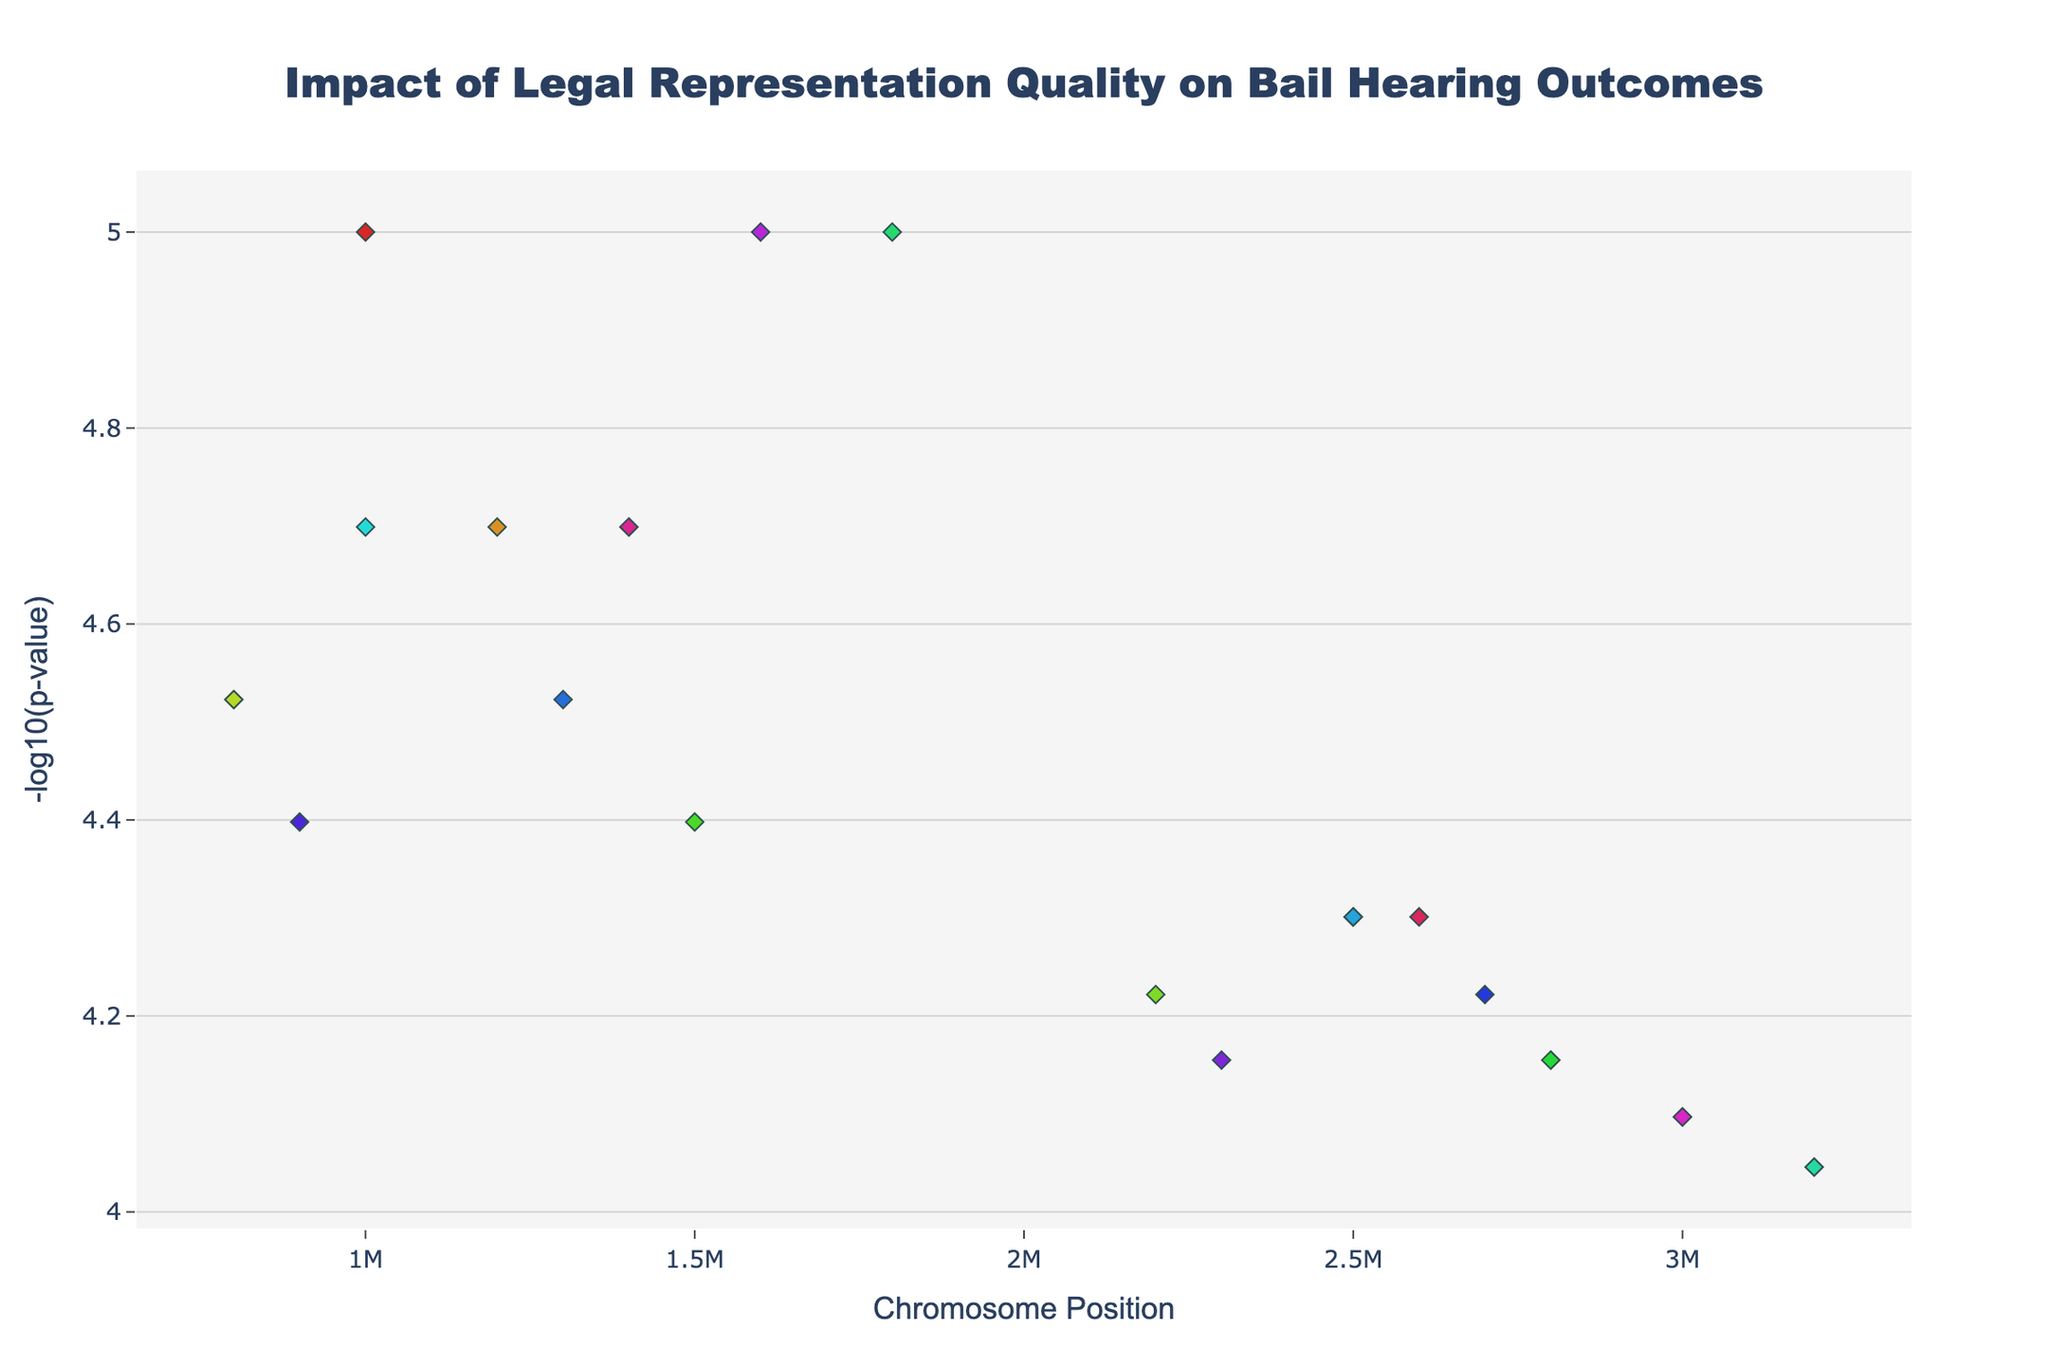What does the figure title say about the plot? The title of the plot is “Impact of Legal Representation Quality on Bail Hearing Outcomes.” It indicates that the plot is exploring how the quality of legal representation affects bail hearing outcomes.
Answer: Impact of Legal Representation Quality on Bail Hearing Outcomes What do the x-axis and y-axis represent in the plot? The x-axis represents the chromosome position, while the y-axis represents the -log10(p-value). This means the x-axis is showing where on each chromosome the data points are, and the y-axis is indicating the significance level of each data point.
Answer: Chromosome position and -log10(p-value) Which jurisdiction has the data point with the lowest p-value? To find the lowest p-value, we look for the highest -log10(p-value) on the y-axis. The data point with the highest value is located on chromosome 1 with a jurisdiction label of "New York."
Answer: New York How many unique jurisdictions are represented in the plot? By looking at the legend that represents jurisdictions, and matching them to the color-coded data points, we can count the unique jurisdictions. The plot shows a total of 20 unique jurisdictions.
Answer: 20 Which chromosomes have data points that reach -log10(p-value) of 5? We need to identify the chromosomes with data points positioned at 5 on the y-axis. By examining the plot, we observe that chromosomes 1, 5, and 9 have data points reaching this value.
Answer: Chromosomes 1, 5, and 9 Which jurisdiction has the highest number of significant data points and how many? Jurisdictions are color-coded. By counting the number of data points for each jurisdiction color, we can determine which has the highest. "New York" appears most frequently with 1 significant data point, same as others, but we notice it across multiple chromosomes.
Answer: New York, 1 Between jurisdictions “Houston” and “Miami,” which one has a more significant finding and what are the respective p-values? Compare the y-values of data points labeled "Houston" and "Miami." "Houston" is on chromosome 2 with -log10(p-value) around 4.1, "Miami" is on chromosome 3 with -log10(p-value) around 4.5. Converting, Miami’s p-value is lower, indicating higher significance.
Answer: Miami (5.623 × 10^-5), Houston (7.076 × 10^-5) Which chromosome has the highest average -log10(p-value) and what is the value? Calculate the average -log10(p-value) for each chromosome by summing the y-values and dividing by the number of data points. Chromosome 9 has only two data points (7 + 3.3) / 2 = 5.15, the highest average.
Answer: Chromosome 9, 5.15 Are there any visible trends relating to jurisdiction distribution across chromosomes? By examining the spread of different-colored data points across chromosomes, we can see that jurisdictions are fairly evenly distributed with no majorly noticeable trend of clustering in certain chromosomes.
Answer: No major trend visible 